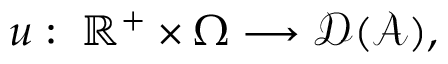Convert formula to latex. <formula><loc_0><loc_0><loc_500><loc_500>u \colon \, \mathbb { R } ^ { + } \times \Omega \longrightarrow \mathcal { D } ( \mathcal { A } ) ,</formula> 